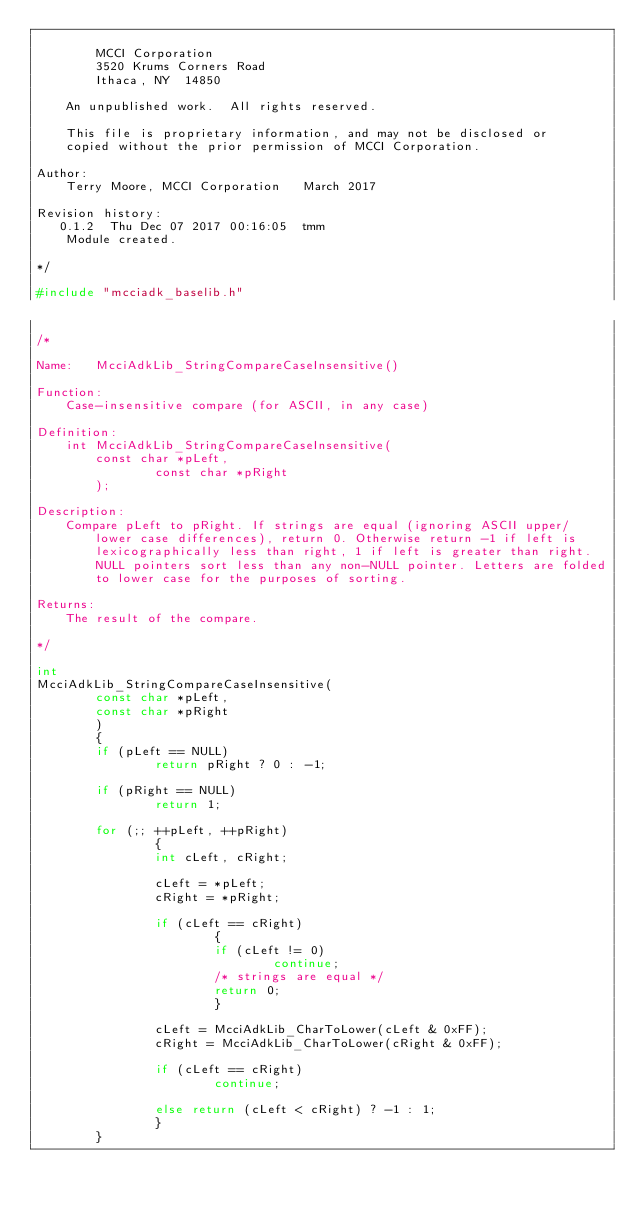Convert code to text. <code><loc_0><loc_0><loc_500><loc_500><_C_>
		MCCI Corporation
		3520 Krums Corners Road
		Ithaca, NY  14850

	An unpublished work.  All rights reserved.

	This file is proprietary information, and may not be disclosed or
	copied without the prior permission of MCCI Corporation.

Author:
	Terry Moore, MCCI Corporation	March 2017

Revision history:
   0.1.2  Thu Dec 07 2017 00:16:05  tmm
	Module created.

*/

#include "mcciadk_baselib.h"

/*

Name:	McciAdkLib_StringCompareCaseInsensitive()

Function:
	Case-insensitive compare (for ASCII, in any case)

Definition:
	int McciAdkLib_StringCompareCaseInsensitive(
		const char *pLeft,
                const char *pRight
		);

Description:
	Compare pLeft to pRight. If strings are equal (ignoring ASCII upper/
        lower case differences), return 0. Otherwise return -1 if left is
        lexicographically less than right, 1 if left is greater than right.
        NULL pointers sort less than any non-NULL pointer. Letters are folded
        to lower case for the purposes of sorting.

Returns:
	The result of the compare.

*/

int
McciAdkLib_StringCompareCaseInsensitive(
        const char *pLeft,
        const char *pRight
        )
        {
        if (pLeft == NULL)
                return pRight ? 0 : -1;

        if (pRight == NULL)
                return 1;

        for (;; ++pLeft, ++pRight)
                {
                int cLeft, cRight;

                cLeft = *pLeft;
                cRight = *pRight;

                if (cLeft == cRight)
                        {
                        if (cLeft != 0)
                                continue;
                        /* strings are equal */
                        return 0;
                        }

                cLeft = McciAdkLib_CharToLower(cLeft & 0xFF);
                cRight = McciAdkLib_CharToLower(cRight & 0xFF);

                if (cLeft == cRight)
                        continue;

                else return (cLeft < cRight) ? -1 : 1;
                }
        }
</code> 